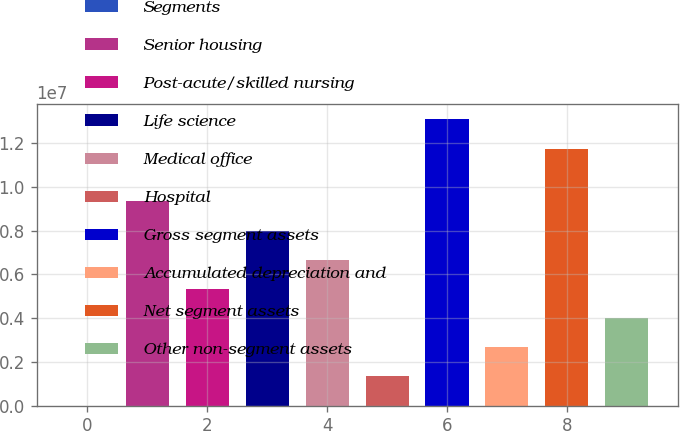Convert chart. <chart><loc_0><loc_0><loc_500><loc_500><bar_chart><fcel>Segments<fcel>Senior housing<fcel>Post-acute/skilled nursing<fcel>Life science<fcel>Medical office<fcel>Hospital<fcel>Gross segment assets<fcel>Accumulated depreciation and<fcel>Net segment assets<fcel>Other non-segment assets<nl><fcel>2010<fcel>9.33295e+06<fcel>5.33398e+06<fcel>7.99996e+06<fcel>6.66697e+06<fcel>1.335e+06<fcel>1.3109e+07<fcel>2.66799e+06<fcel>1.17221e+07<fcel>4.00098e+06<nl></chart> 